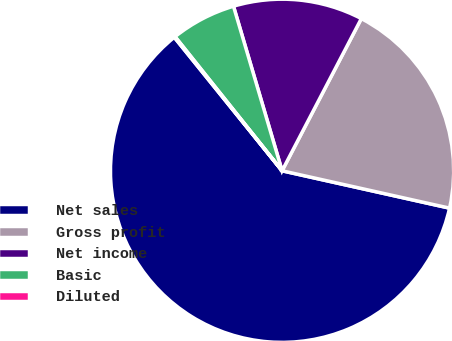<chart> <loc_0><loc_0><loc_500><loc_500><pie_chart><fcel>Net sales<fcel>Gross profit<fcel>Net income<fcel>Basic<fcel>Diluted<nl><fcel>60.69%<fcel>20.85%<fcel>12.21%<fcel>6.15%<fcel>0.09%<nl></chart> 